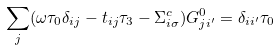Convert formula to latex. <formula><loc_0><loc_0><loc_500><loc_500>\sum _ { j } ( \omega \tau _ { 0 } \delta _ { i j } - t _ { i j } \tau _ { 3 } - \Sigma ^ { c } _ { i \sigma } ) G ^ { 0 } _ { j i ^ { \prime } } = \delta _ { i i ^ { \prime } } \tau _ { 0 }</formula> 